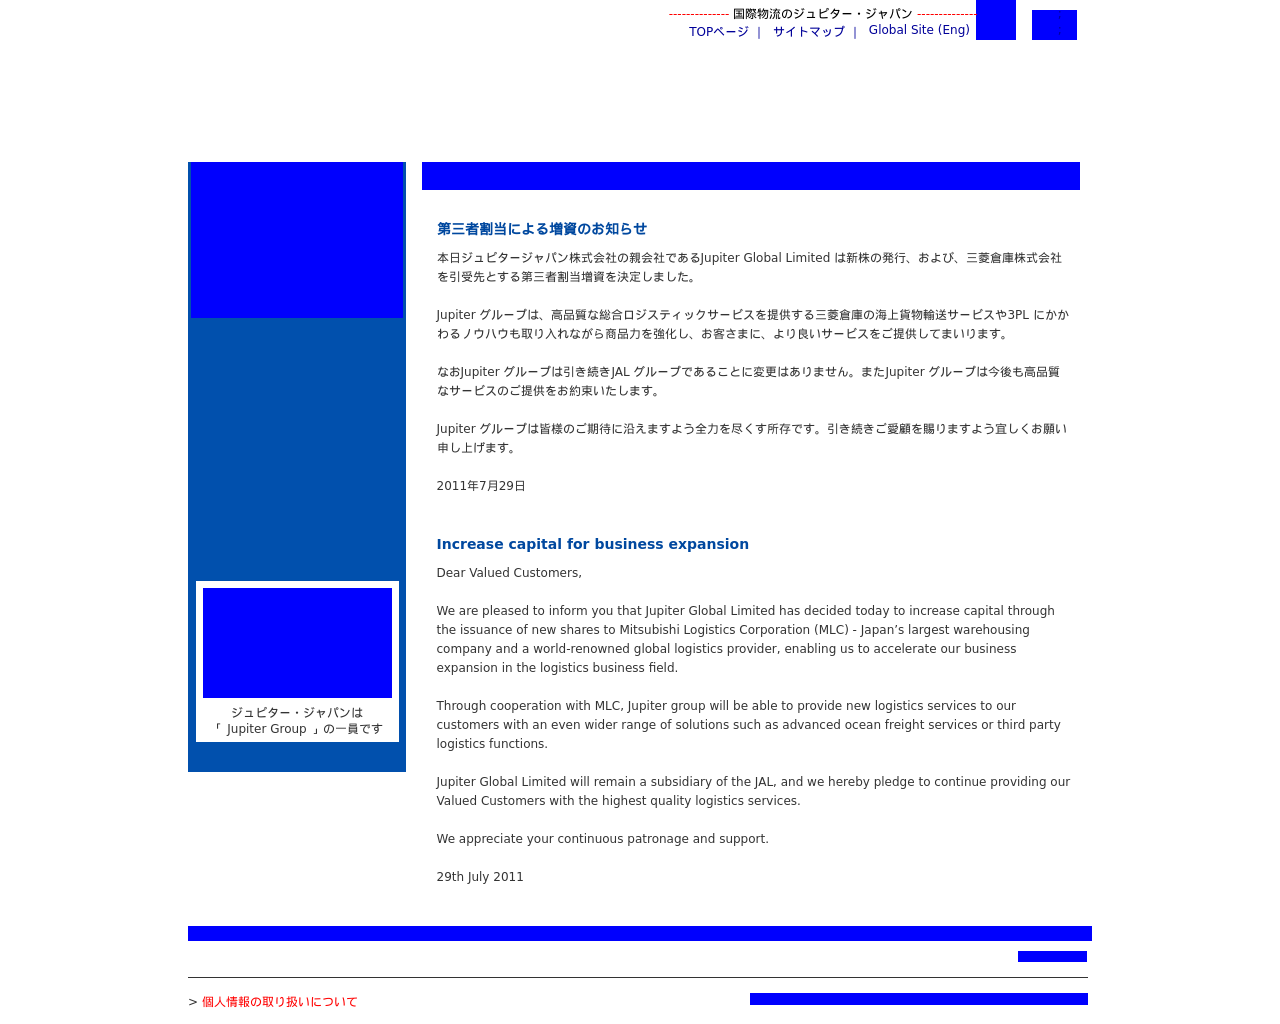What does the blue color scheme in the image signify in a business context? The blue color scheme used in the website's design could symbolize professionalism, reliability, and trust. In a business context, blue often represents these qualities and is widely used to convey a sense of stability and corporate responsibility. It's a strategic choice to instill confidence among existing and potential customers about the company's dependable services. Does the design enhance readability and user engagement? Yes, the clean layout and structured design enhance readability and help in maintaining user engagement. The use of clear headers, bullet points, and well-spaced text ensures that information is easy to digest. Also, the prominent display of important updates right at the top draws immediate attention, which is effective for important notices. 